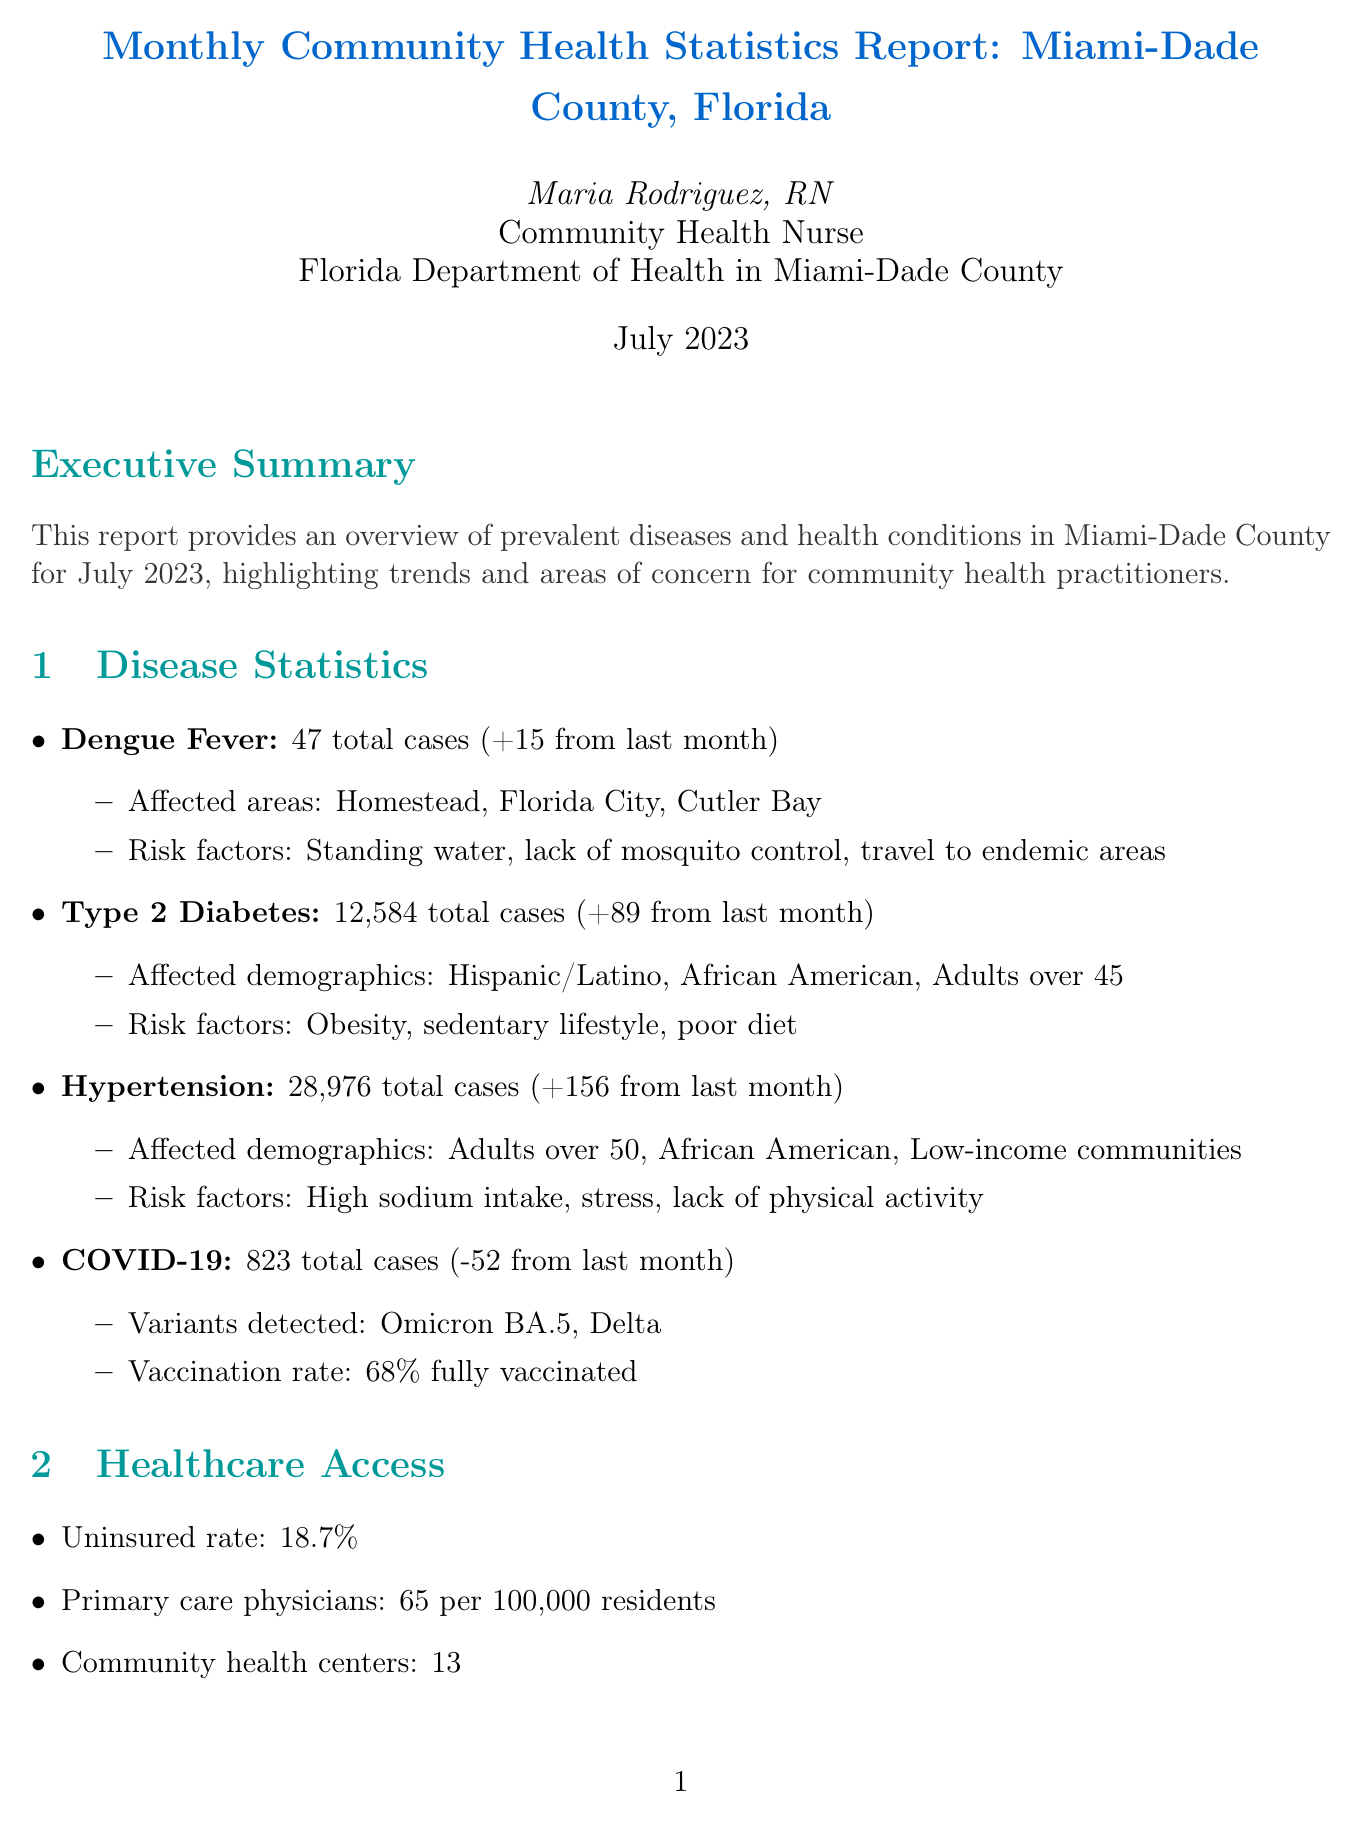What was the total number of Dengue Fever cases? The total number of Dengue Fever cases reported this month is 47.
Answer: 47 Which disease had the highest number of total cases? Hypertension had the highest total cases, with 28,976 cases reported.
Answer: Hypertension What was the vaccination rate for COVID-19? The vaccination rate for COVID-19 in July 2023 is 68% fully vaccinated.
Answer: 68% fully vaccinated Which community initiative had a reduction in new diabetes cases among participants? The Diabetes Prevention Program reported a 15% reduction in new diabetes cases among participants.
Answer: Diabetes Prevention Program What is the uninsured rate in Miami-Dade County? The uninsured rate reported is 18.7%.
Answer: 18.7% How many primary care physicians are available per 100,000 residents? There are 65 primary care physicians available per 100,000 residents.
Answer: 65 per 100,000 residents What are the locations where Dengue Fever cases were reported? Dengue Fever cases were reported in Homestead, Florida City, and Cutler Bay.
Answer: Homestead, Florida City, Cutler Bay How many community health centers are mentioned in the report? The report mentions a total of 13 community health centers.
Answer: 13 What is the average Air Quality Index rating? The average Air Quality Index rating is 52, which is rated as Moderate.
Answer: 52 